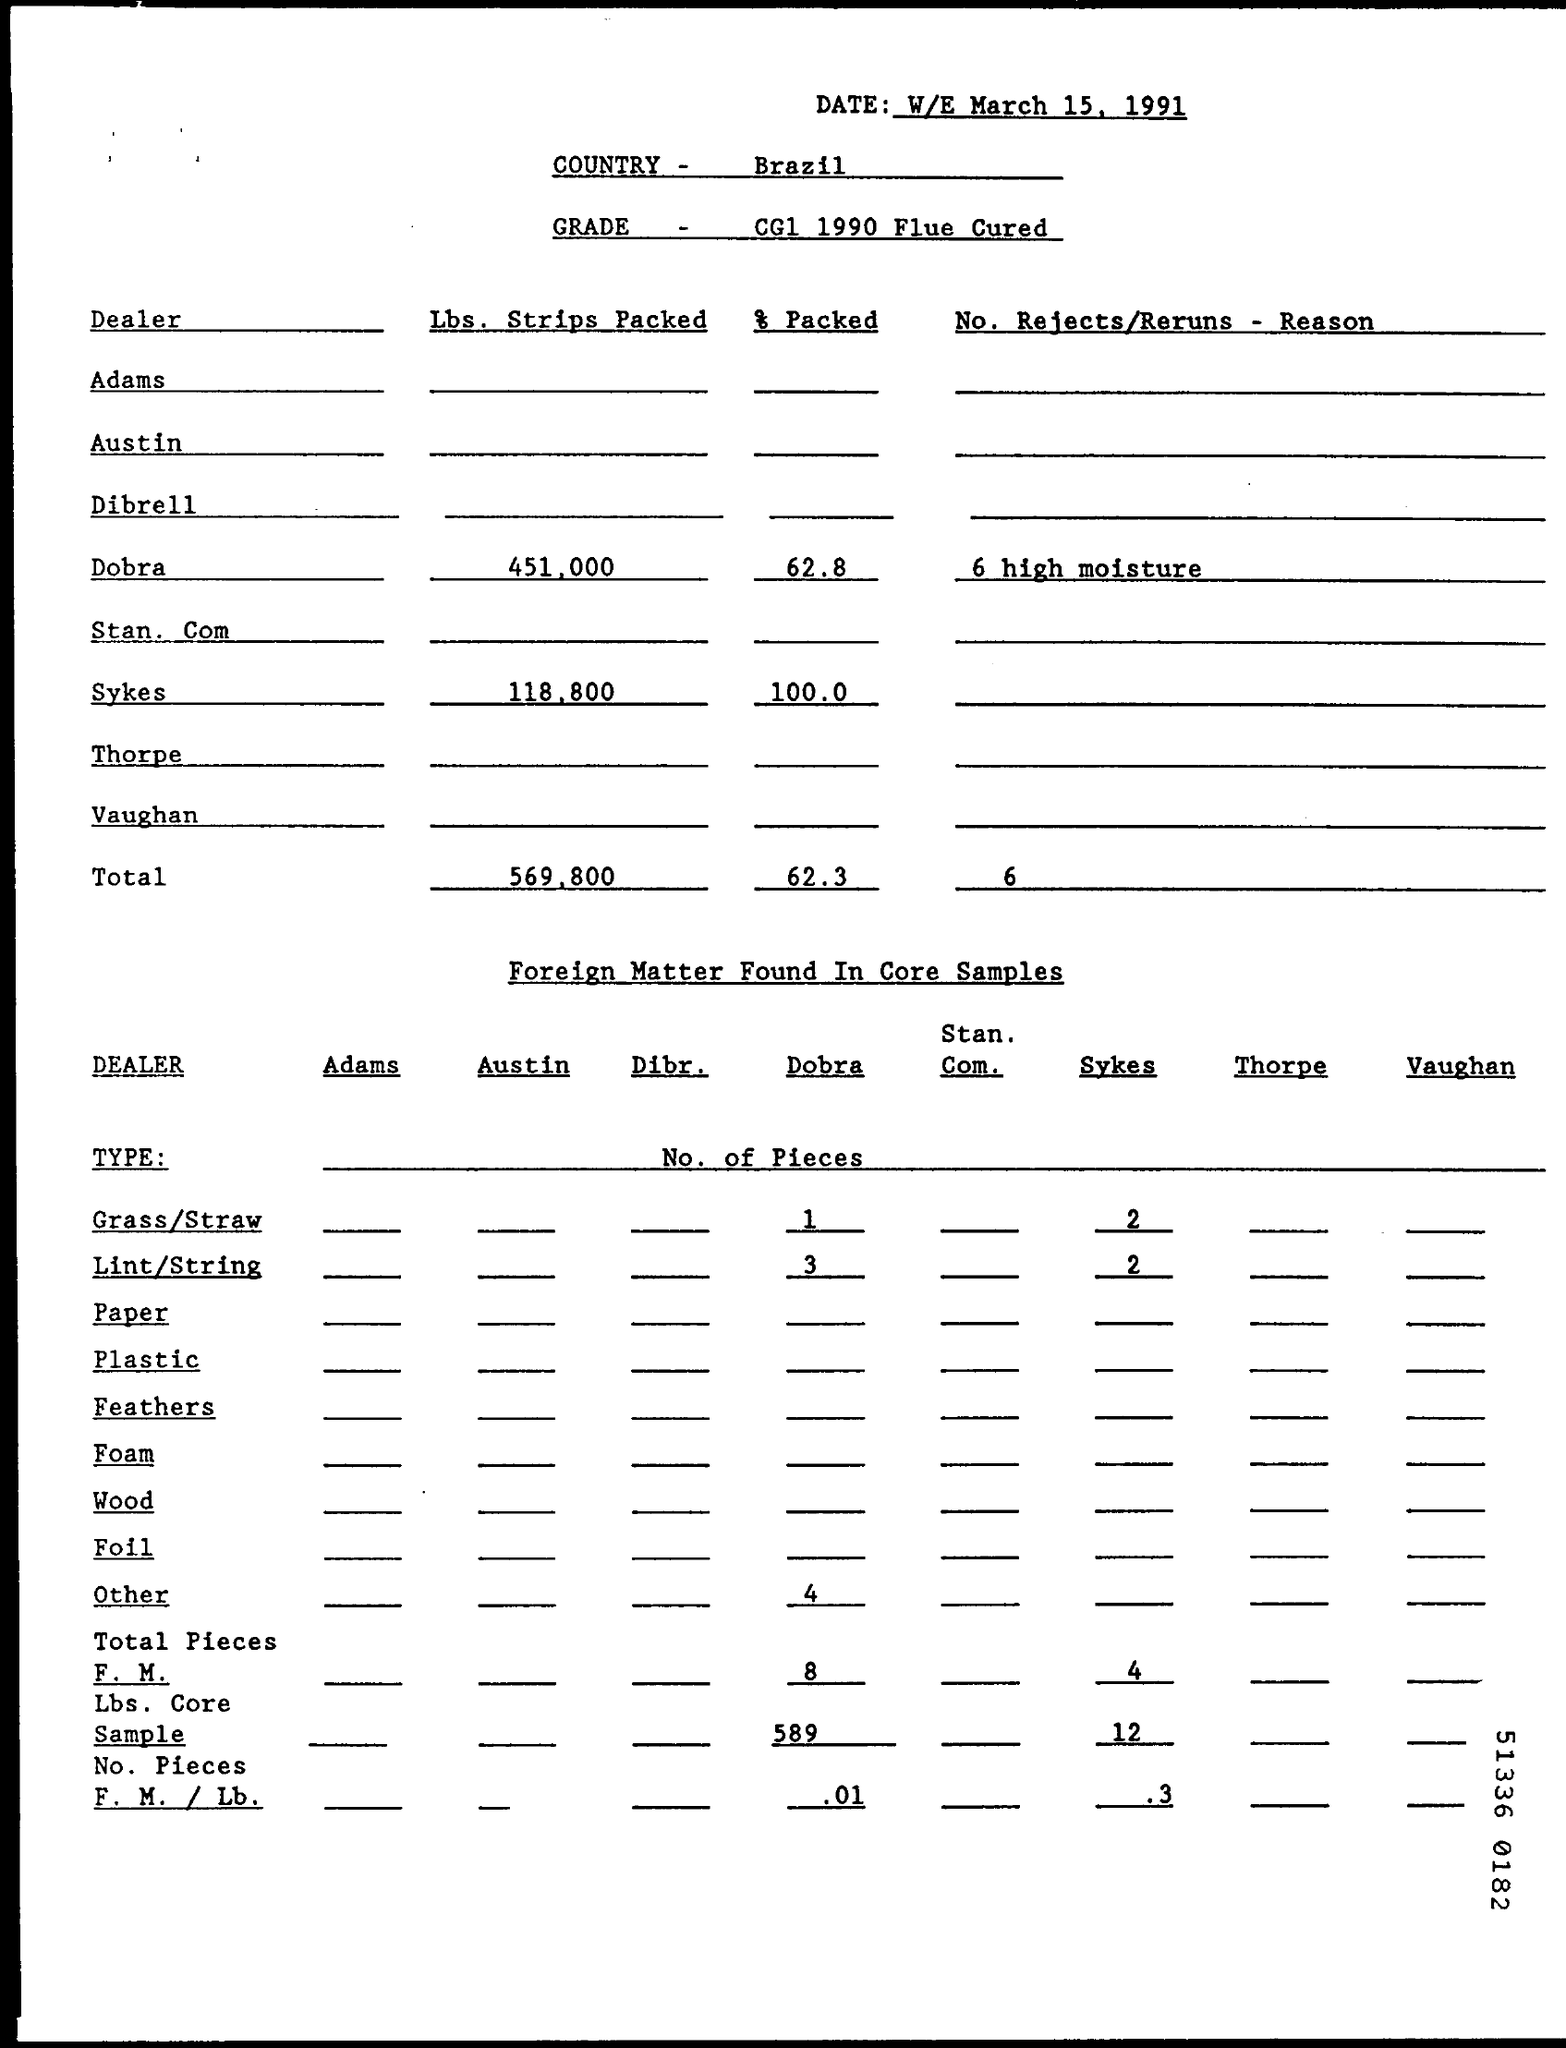What is the date on the document?
Provide a short and direct response. W/E March 15, 1991. What is the Country?
Offer a terse response. Brazil. What are the Lbs. Strips Packed for Dobra?
Make the answer very short. 451,000. What are the Lbs. Strips Packed for Sykes?
Your answer should be very brief. 118,800. What is the Total Lbs. Strips Packed?
Ensure brevity in your answer.  569,800. What is the % packed for sykes?
Your answer should be very brief. 100.0. What is the total % packed ?
Offer a terse response. 62.3. What are the No. of pieces of Dobra with Grass/Straw?
Provide a short and direct response. 1. 